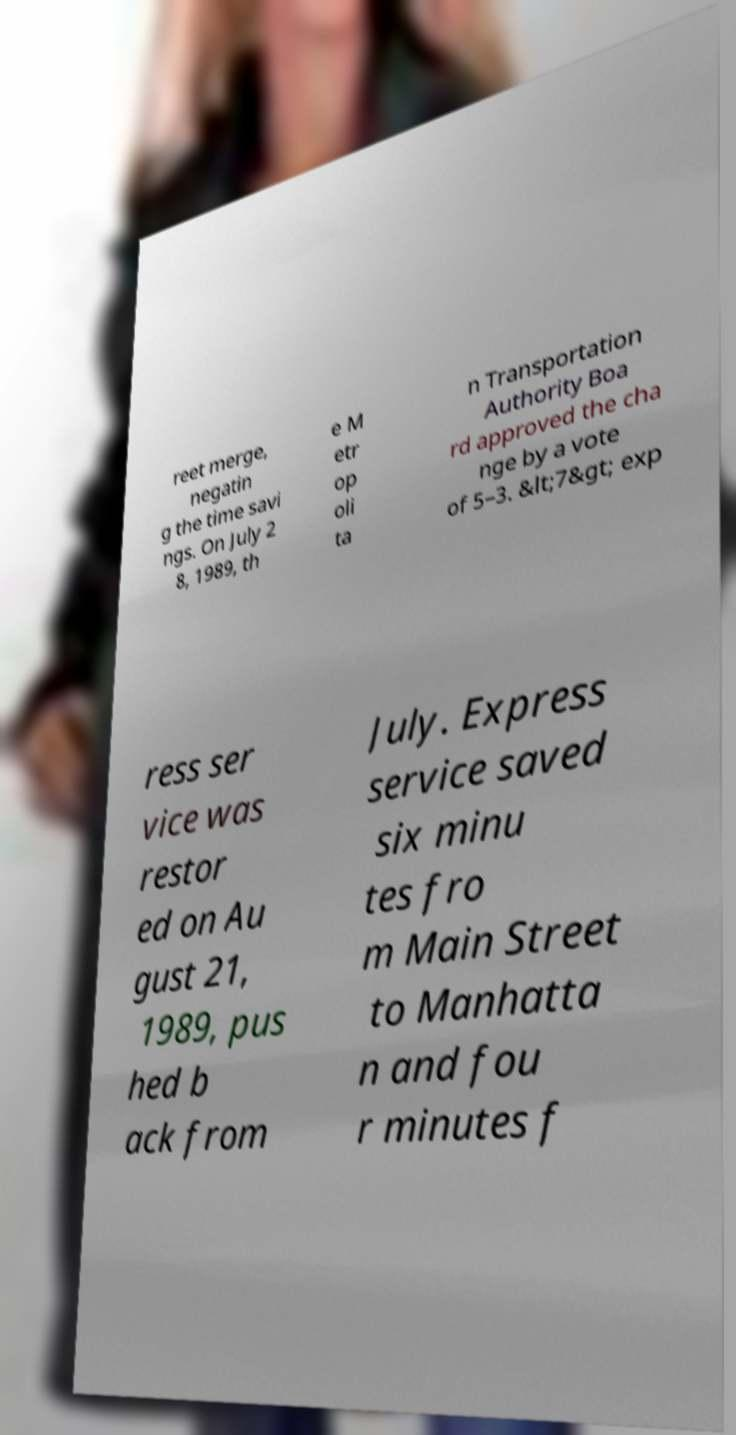Can you read and provide the text displayed in the image?This photo seems to have some interesting text. Can you extract and type it out for me? reet merge, negatin g the time savi ngs. On July 2 8, 1989, th e M etr op oli ta n Transportation Authority Boa rd approved the cha nge by a vote of 5–3. &lt;7&gt; exp ress ser vice was restor ed on Au gust 21, 1989, pus hed b ack from July. Express service saved six minu tes fro m Main Street to Manhatta n and fou r minutes f 